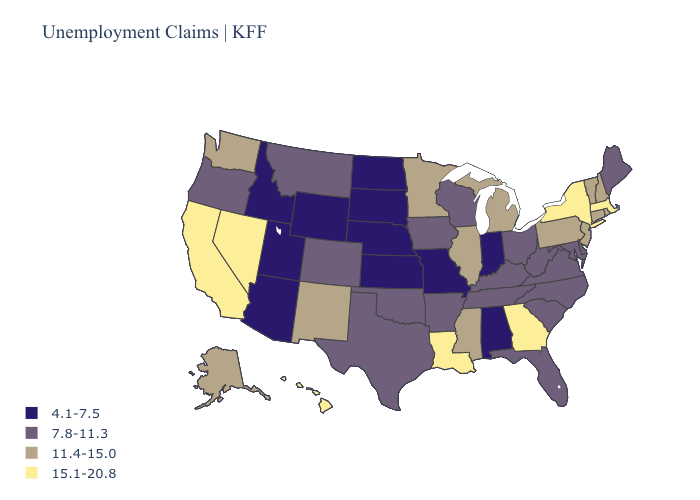What is the value of Louisiana?
Give a very brief answer. 15.1-20.8. What is the value of Colorado?
Be succinct. 7.8-11.3. What is the highest value in the Northeast ?
Give a very brief answer. 15.1-20.8. What is the lowest value in states that border New York?
Write a very short answer. 11.4-15.0. Does Oklahoma have the same value as Texas?
Answer briefly. Yes. What is the value of Iowa?
Write a very short answer. 7.8-11.3. Does the first symbol in the legend represent the smallest category?
Concise answer only. Yes. What is the highest value in the USA?
Quick response, please. 15.1-20.8. What is the value of South Dakota?
Answer briefly. 4.1-7.5. What is the value of Delaware?
Write a very short answer. 7.8-11.3. What is the value of Georgia?
Short answer required. 15.1-20.8. What is the value of Illinois?
Be succinct. 11.4-15.0. What is the lowest value in the West?
Short answer required. 4.1-7.5. What is the highest value in the USA?
Short answer required. 15.1-20.8. Does Pennsylvania have the lowest value in the Northeast?
Write a very short answer. No. 